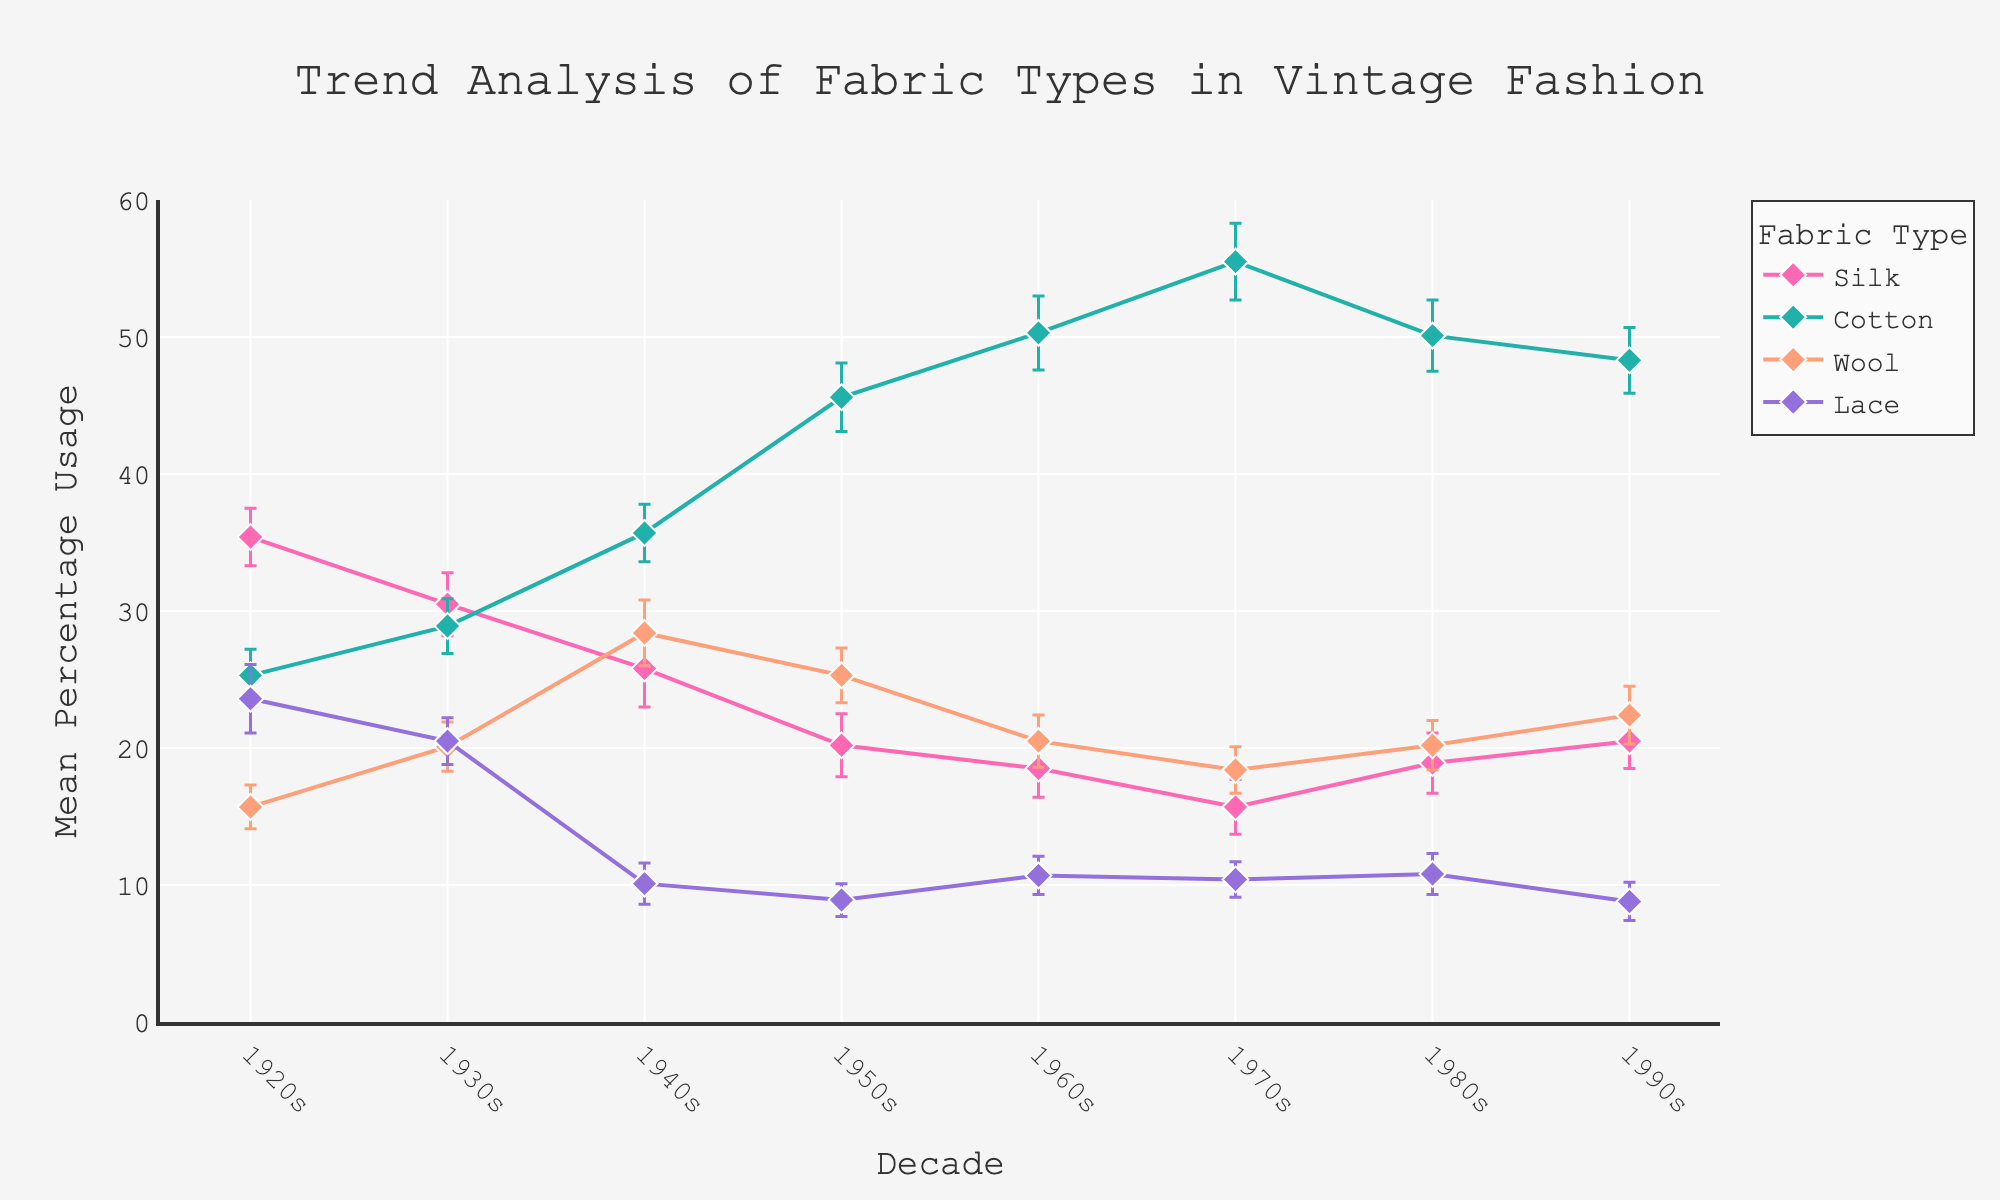What's the title of the figure? The title is positioned at the top center of the figure. Reading this area reveals that the title is "Trend Analysis of Fabric Types in Vintage Fashion".
Answer: Trend Analysis of Fabric Types in Vintage Fashion What does the y-axis represent? The y-axis title, which is located to the left of the axis, indicates that it represents "Mean Percentage Usage".
Answer: Mean Percentage Usage Which fabric type had the highest mean percentage usage in the 1950s? Observing the data points for the 1950s and checking their mean percentage usages, cotton has the highest value at 45.6%.
Answer: Cotton What decade had the highest mean percentage usage of cotton? By identifying the data points for each decade related to cotton, the 1970s show the highest mean percentage usage at 55.5%.
Answer: 1970s How did the mean percentage usage of silk change from the 1920s to the 1990s? Analyzing the data points for silk from the 1920s and 1990s, the usage decreased from 35.4% to 20.5%.
Answer: Decreased For which decade does the mean percentage usage of lace show the greatest decrease compared to the previous decade? Looking at the mean usage of lace across decades, the largest drop is from the 1930s (20.5%) to the 1940s (10.1%).
Answer: 1940s Compare the mean percentage usage of wool in the 1920s and the 1960s. Which decade had a higher usage? By looking at the data points, wool usage in the 1920s was 15.7% and in the 1960s was 20.5%, showing higher usage in the 1960s.
Answer: 1960s What is the range of mean percentage usage of silk across all decades? The highest mean percentage usage of silk is in the 1920s (35.4%) and the lowest is in the 1970s (15.7%), resulting in a range of 19.7 (35.4 - 15.7).
Answer: 19.7 Which fabric type shows the most consistent usage across the decades based on the error bars? By examining the error bars for all fabric types, wool shows relatively smaller and consistent error bars, indicating more consistent usage.
Answer: Wool What trend can you observe for the usage of cotton from the 1920s to the 1990s? The data points for cotton across these decades show a general increasing trend peaking in the 1970s and then slightly decreasing towards the 1990s.
Answer: Increasing then slightly decreasing 